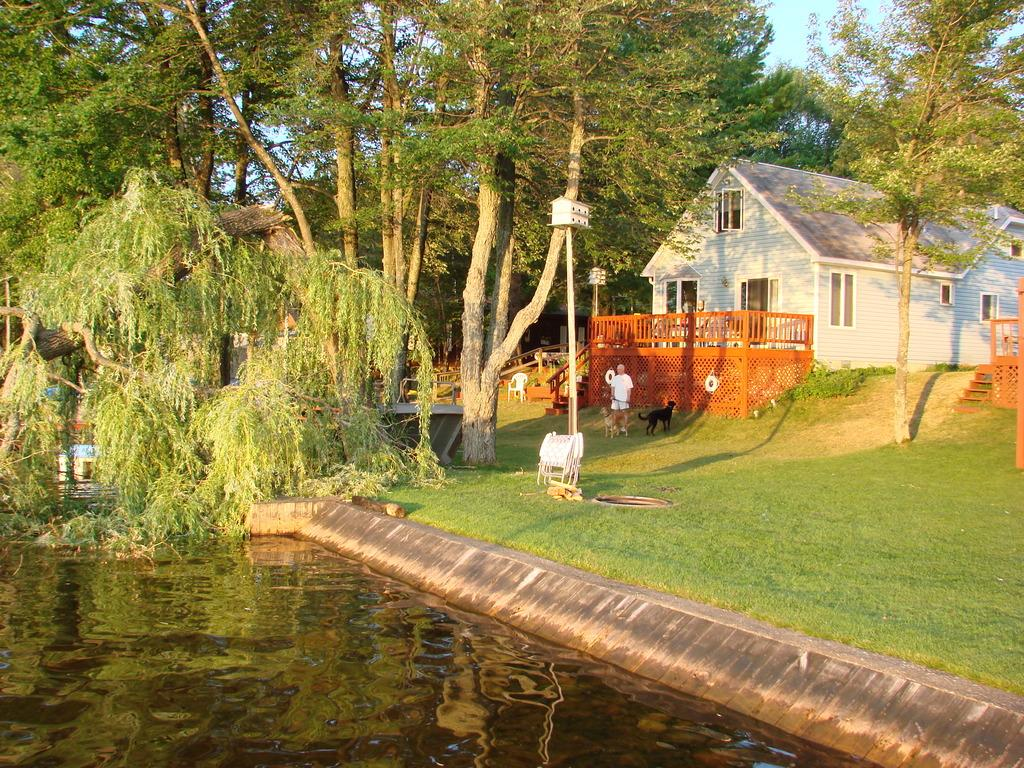What type of structure is visible in the image? There is a house in the image. Where is the house located in relation to the trees? The house is situated between trees. What body of water is present at the bottom of the image? There is a canal at the bottom of the image. Can you identify any living beings in the image? Yes, there is a person and dogs in the image. What message is written on the mailbox in the image? There is no mailbox present in the image, so it is not possible to answer that question. 